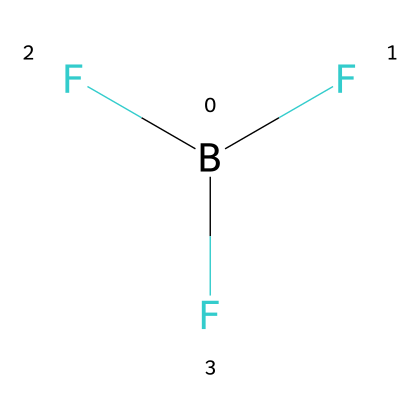What is the molecular formula of this compound? The SMILES representation B(F)(F)F indicates the presence of one boron atom (B) and three fluorine atoms (F), which together form the molecular formula BF3.
Answer: BF3 How many fluorine atoms are in this molecule? The structure shows three fluorine atoms attached to a single boron atom, indicated by the three 'F' elements in the SMILES.
Answer: 3 What type of bonding is present in boron trifluoride? The compound features covalent bonding, as it involves shared pairs of electrons between the boron and fluorine atoms, a characteristic of molecular compounds like boron trifluoride.
Answer: covalent What is the hybridization of the boron atom in this compound? In BF3, the boron atom has three regions of electron density (the bonds with fluorine), which corresponds to sp2 hybridization according to VSEPR theory.
Answer: sp2 Is boron trifluoride a Lewis acid or base? Boron trifluoride is a Lewis acid because it can accept electron pairs due to the electron-deficient nature of boron.
Answer: Lewis acid What is the geometry of the boron trifluoride molecule? The arrangement of the three fluorine atoms around the boron atom, with sp2 hybridization, results in a trigonal planar geometry according to VSEPR theory.
Answer: trigonal planar What is the primary application of boron trifluoride? Boron trifluoride is primarily used as a catalyst and a reagent in various chemical reactions, particularly in electronics manufacturing.
Answer: catalyst 